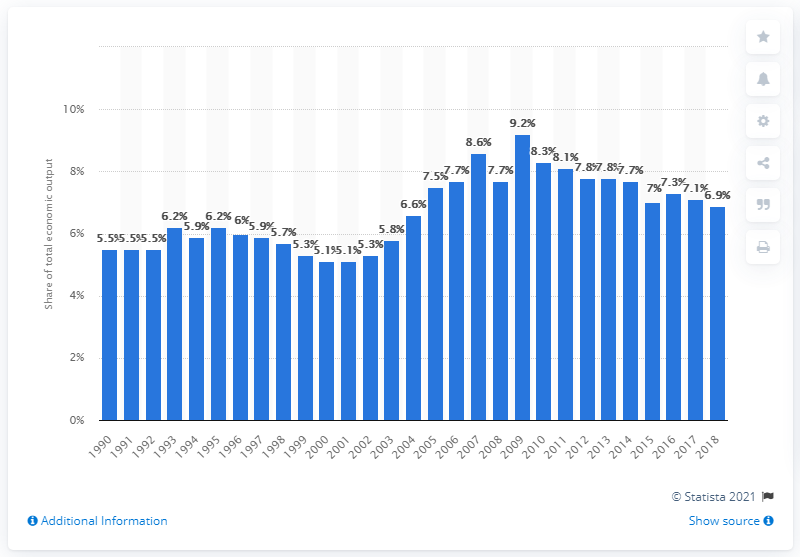Identify some key points in this picture. In 2018, the GVA (Gross Value Added) of the UK's finance and insurance industry was 6.9 billion pounds. 